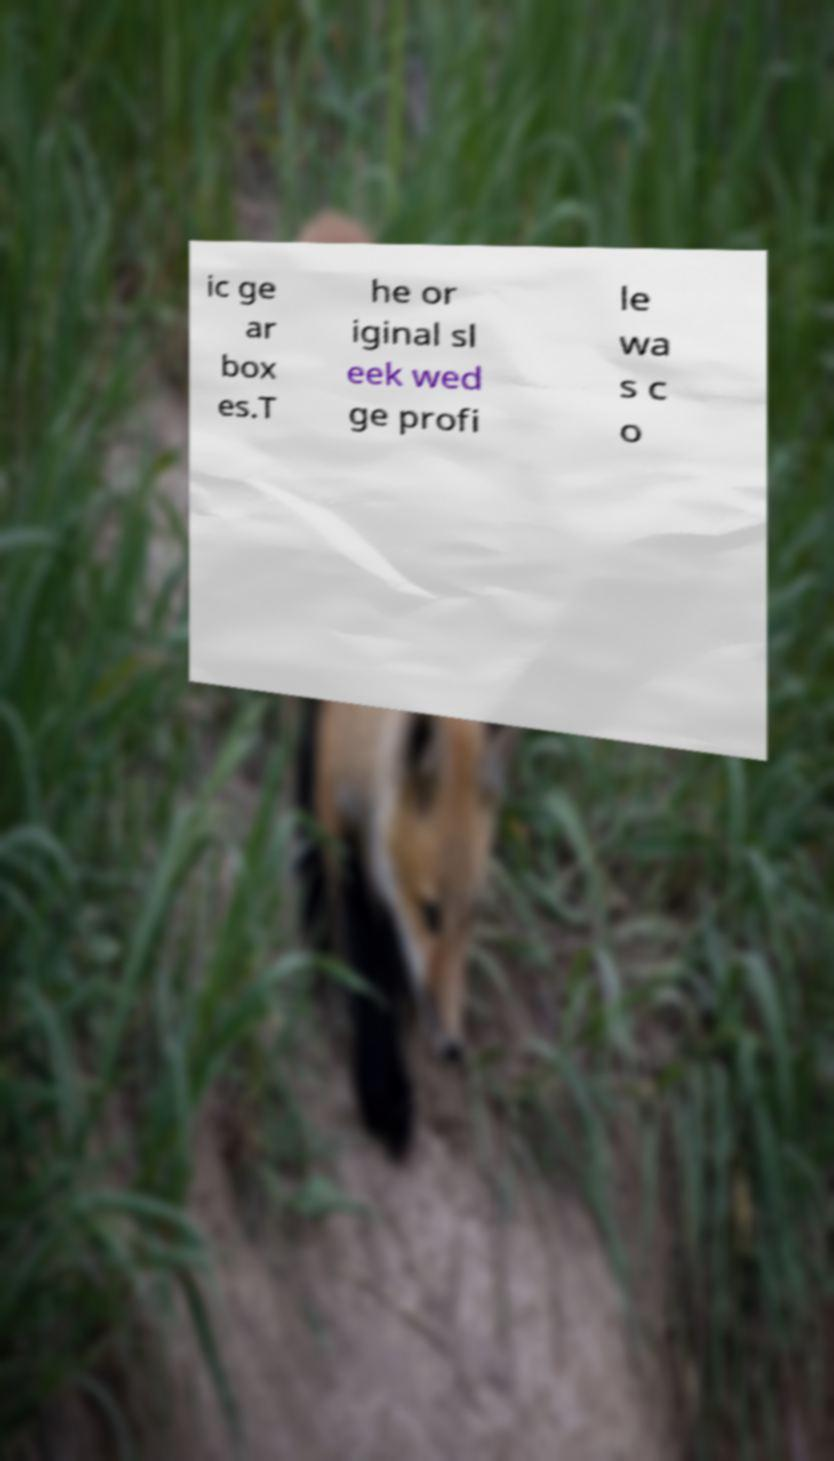Can you accurately transcribe the text from the provided image for me? ic ge ar box es.T he or iginal sl eek wed ge profi le wa s c o 